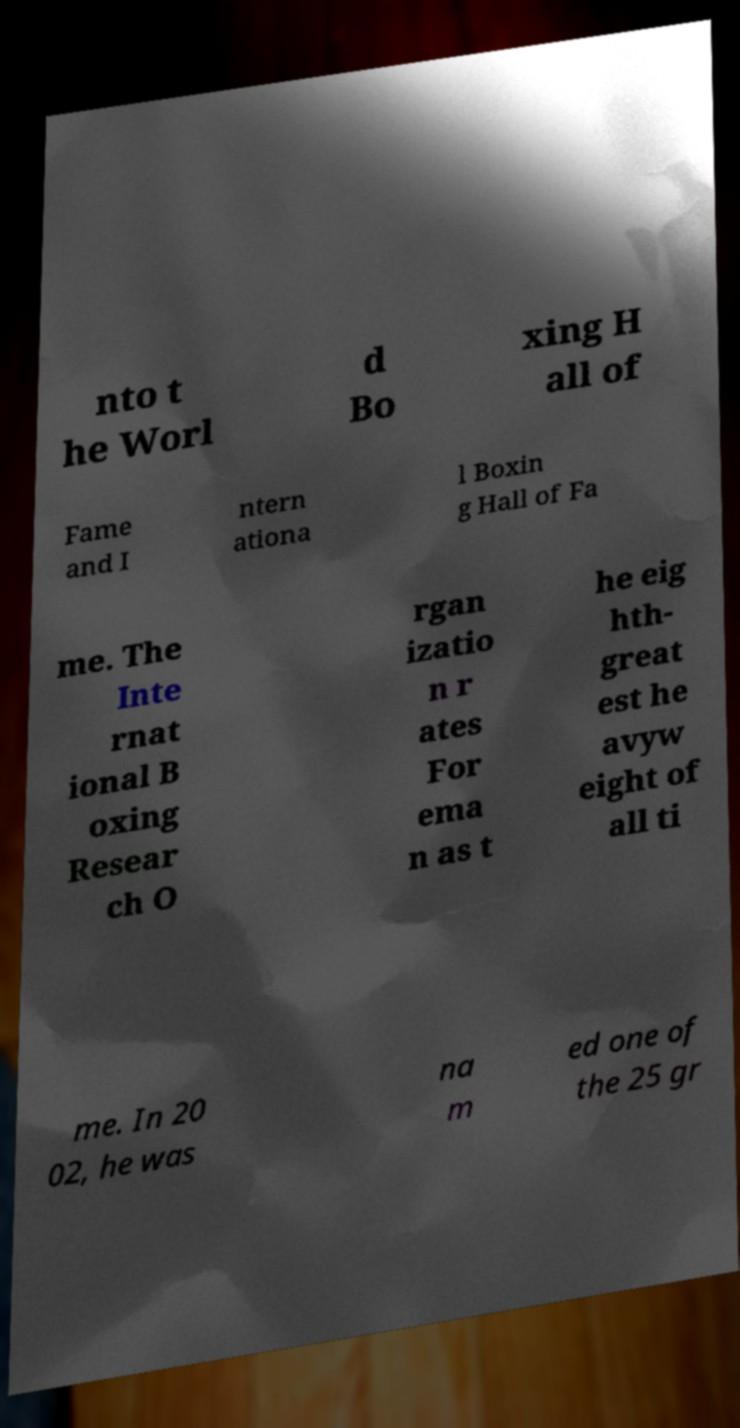I need the written content from this picture converted into text. Can you do that? nto t he Worl d Bo xing H all of Fame and I ntern ationa l Boxin g Hall of Fa me. The Inte rnat ional B oxing Resear ch O rgan izatio n r ates For ema n as t he eig hth- great est he avyw eight of all ti me. In 20 02, he was na m ed one of the 25 gr 